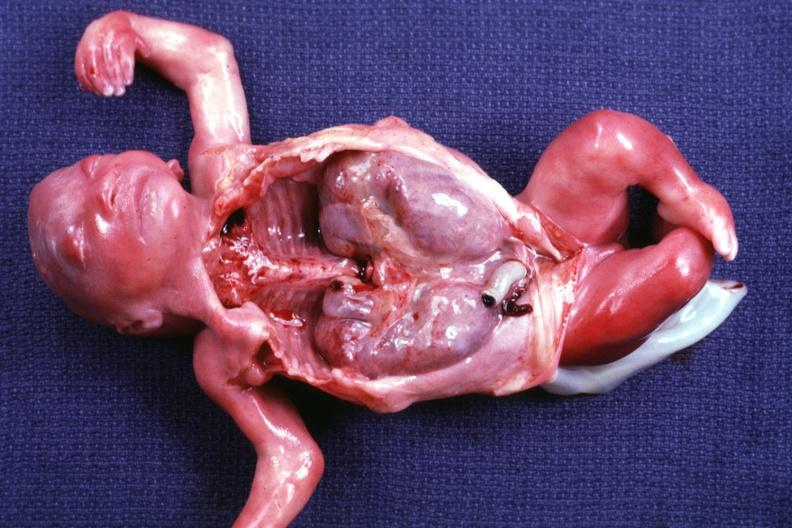does this image show opened dysmorphic body with all organs except kidneys removed shows size of organs quite well and renal facies?
Answer the question using a single word or phrase. Yes 